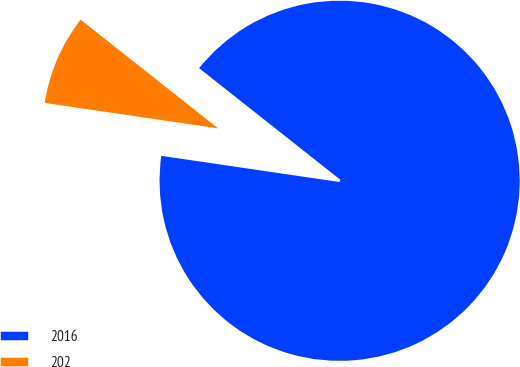<chart> <loc_0><loc_0><loc_500><loc_500><pie_chart><fcel>2016<fcel>202<nl><fcel>91.68%<fcel>8.32%<nl></chart> 